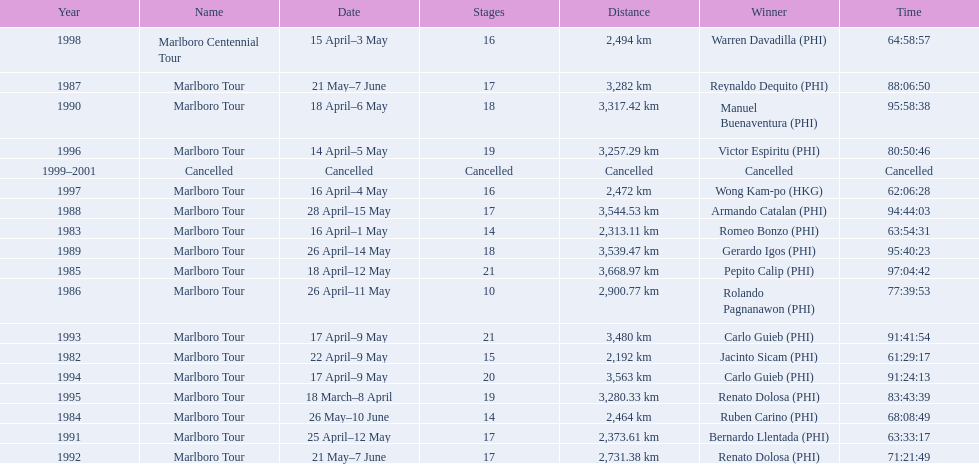Which year did warren davdilla (w.d.) appear? 1998. What tour did w.d. complete? Marlboro Centennial Tour. Can you give me this table in json format? {'header': ['Year', 'Name', 'Date', 'Stages', 'Distance', 'Winner', 'Time'], 'rows': [['1998', 'Marlboro Centennial Tour', '15 April–3 May', '16', '2,494\xa0km', 'Warren Davadilla\xa0(PHI)', '64:58:57'], ['1987', 'Marlboro Tour', '21 May–7 June', '17', '3,282\xa0km', 'Reynaldo Dequito\xa0(PHI)', '88:06:50'], ['1990', 'Marlboro Tour', '18 April–6 May', '18', '3,317.42\xa0km', 'Manuel Buenaventura\xa0(PHI)', '95:58:38'], ['1996', 'Marlboro Tour', '14 April–5 May', '19', '3,257.29\xa0km', 'Victor Espiritu\xa0(PHI)', '80:50:46'], ['1999–2001', 'Cancelled', 'Cancelled', 'Cancelled', 'Cancelled', 'Cancelled', 'Cancelled'], ['1997', 'Marlboro Tour', '16 April–4 May', '16', '2,472\xa0km', 'Wong Kam-po\xa0(HKG)', '62:06:28'], ['1988', 'Marlboro Tour', '28 April–15 May', '17', '3,544.53\xa0km', 'Armando Catalan\xa0(PHI)', '94:44:03'], ['1983', 'Marlboro Tour', '16 April–1 May', '14', '2,313.11\xa0km', 'Romeo Bonzo\xa0(PHI)', '63:54:31'], ['1989', 'Marlboro Tour', '26 April–14 May', '18', '3,539.47\xa0km', 'Gerardo Igos\xa0(PHI)', '95:40:23'], ['1985', 'Marlboro Tour', '18 April–12 May', '21', '3,668.97\xa0km', 'Pepito Calip\xa0(PHI)', '97:04:42'], ['1986', 'Marlboro Tour', '26 April–11 May', '10', '2,900.77\xa0km', 'Rolando Pagnanawon\xa0(PHI)', '77:39:53'], ['1993', 'Marlboro Tour', '17 April–9 May', '21', '3,480\xa0km', 'Carlo Guieb\xa0(PHI)', '91:41:54'], ['1982', 'Marlboro Tour', '22 April–9 May', '15', '2,192\xa0km', 'Jacinto Sicam\xa0(PHI)', '61:29:17'], ['1994', 'Marlboro Tour', '17 April–9 May', '20', '3,563\xa0km', 'Carlo Guieb\xa0(PHI)', '91:24:13'], ['1995', 'Marlboro Tour', '18 March–8 April', '19', '3,280.33\xa0km', 'Renato Dolosa\xa0(PHI)', '83:43:39'], ['1984', 'Marlboro Tour', '26 May–10 June', '14', '2,464\xa0km', 'Ruben Carino\xa0(PHI)', '68:08:49'], ['1991', 'Marlboro Tour', '25 April–12 May', '17', '2,373.61\xa0km', 'Bernardo Llentada\xa0(PHI)', '63:33:17'], ['1992', 'Marlboro Tour', '21 May–7 June', '17', '2,731.38\xa0km', 'Renato Dolosa\xa0(PHI)', '71:21:49']]} What is the time recorded in the same row as w.d.? 64:58:57. 